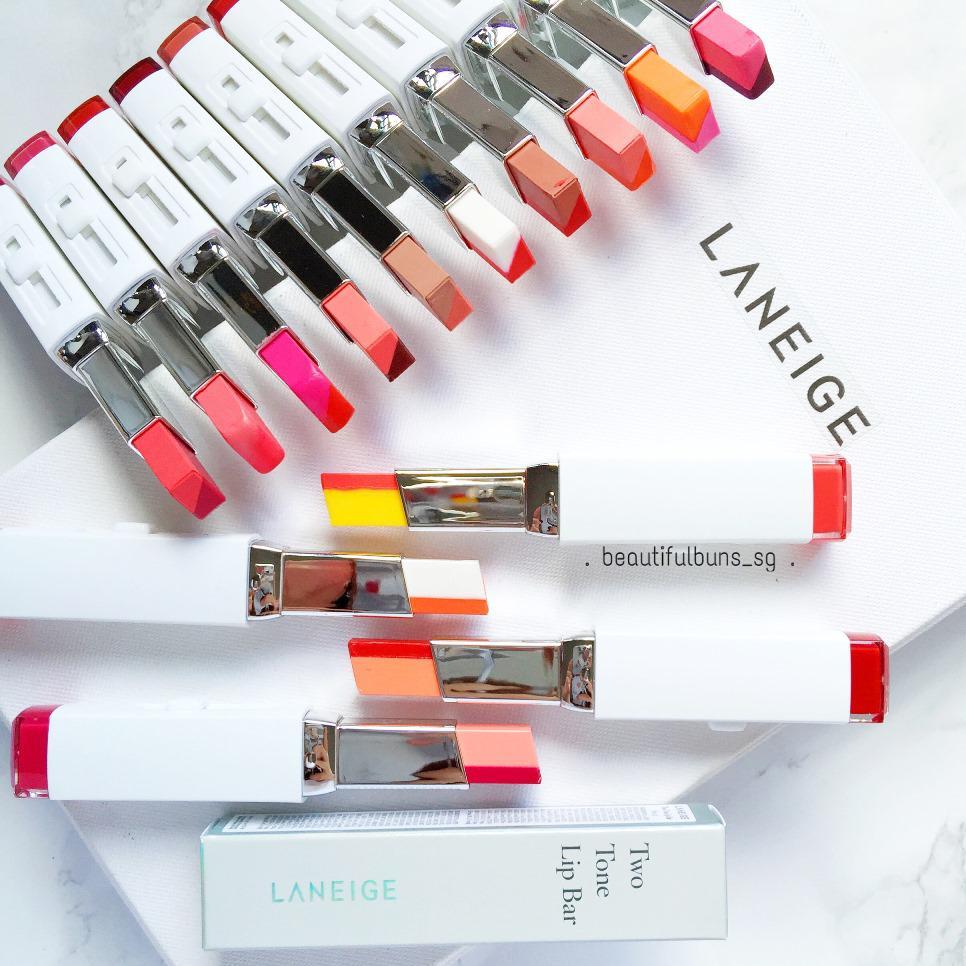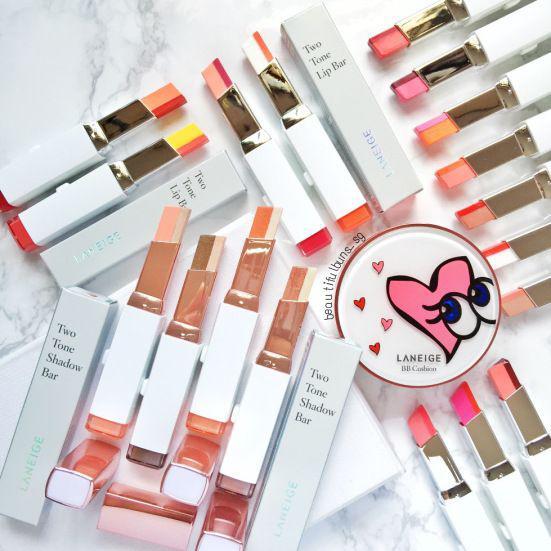The first image is the image on the left, the second image is the image on the right. Given the left and right images, does the statement "An image shows a collage of at least ten painted pairs of lips." hold true? Answer yes or no. No. The first image is the image on the left, the second image is the image on the right. Analyze the images presented: Is the assertion "One image shows 5 or more tubes of lipstick, and the other shows how the colors look when applied to the lips." valid? Answer yes or no. No. 